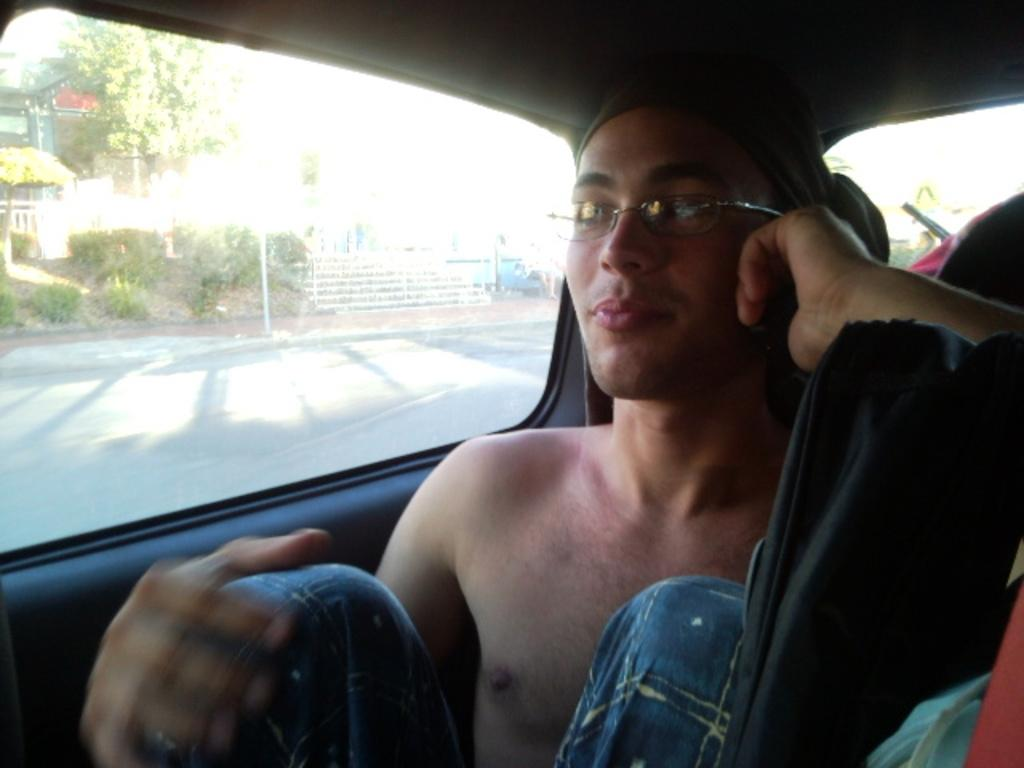What is the person in the image doing? There is a person sitting in a car in the image. What can be seen inside the car? There are objects inside the car. What is visible in the background of the image? There are trees, a pole, and buildings in the background of the image. How many patches can be seen on the person's clothing in the image? There is no information about the person's clothing in the image, so it is impossible to determine the number of patches. 